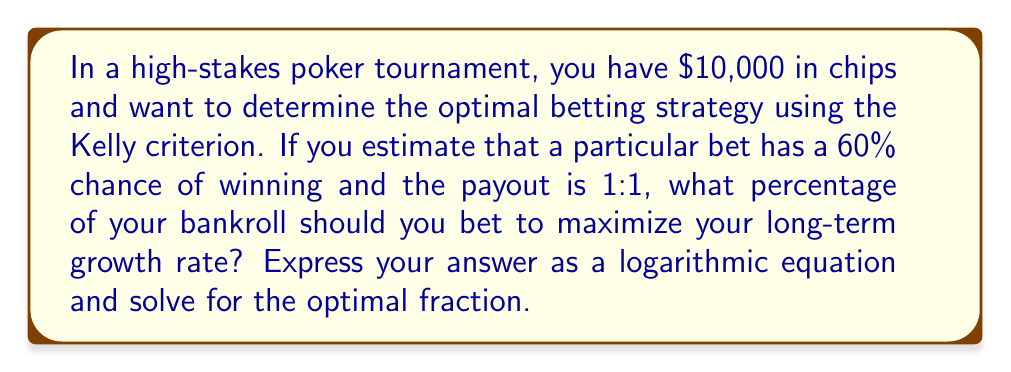Can you solve this math problem? To solve this problem, we'll use the Kelly criterion, which uses logarithmic functions to determine the optimal betting fraction. Let's approach this step-by-step:

1) The Kelly criterion formula is:

   $$f = p - \frac{q}{b}$$

   Where:
   $f$ = fraction of bankroll to bet
   $p$ = probability of winning
   $q$ = probability of losing (1 - p)
   $b$ = net odds received on the bet (amount won per unit bet)

2) Given:
   $p = 0.60$ (60% chance of winning)
   $q = 1 - p = 0.40$ (40% chance of losing)
   $b = 1$ (1:1 payout)

3) Substituting these values into the formula:

   $$f = 0.60 - \frac{0.40}{1} = 0.60 - 0.40 = 0.20$$

4) To express this as a logarithmic equation, we can use the formula for expected value of the logarithm of wealth:

   $$E[\log(W)] = p \cdot \log(1 + b \cdot f) + q \cdot \log(1 - f)$$

5) Substituting our values:

   $$E[\log(W)] = 0.60 \cdot \log(1 + 1 \cdot f) + 0.40 \cdot \log(1 - f)$$

6) To find the maximum of this function, we would differentiate with respect to $f$ and set it to zero. However, we've already calculated $f = 0.20$ using the Kelly criterion.

7) Therefore, the optimal fraction to bet is 20% of your bankroll, or $2,000 out of your $10,000 chips.
Answer: $f = 0.20$ or 20% of bankroll 